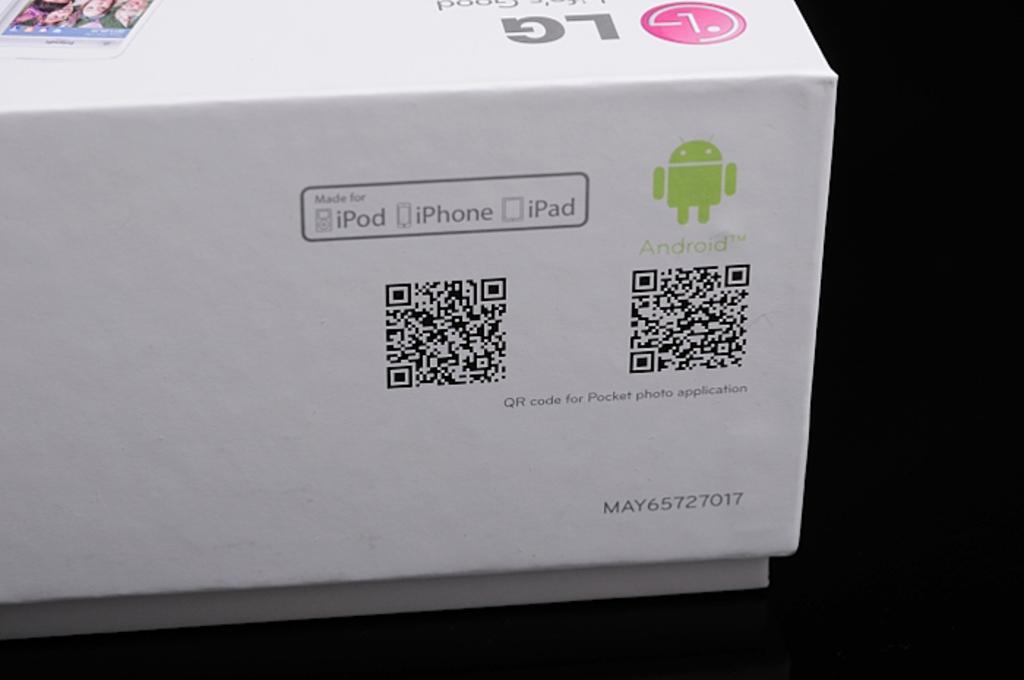What is the qr code for?
Provide a succinct answer. Pocket photo application. What product works with iphone and android?
Ensure brevity in your answer.  Unanswerable. 